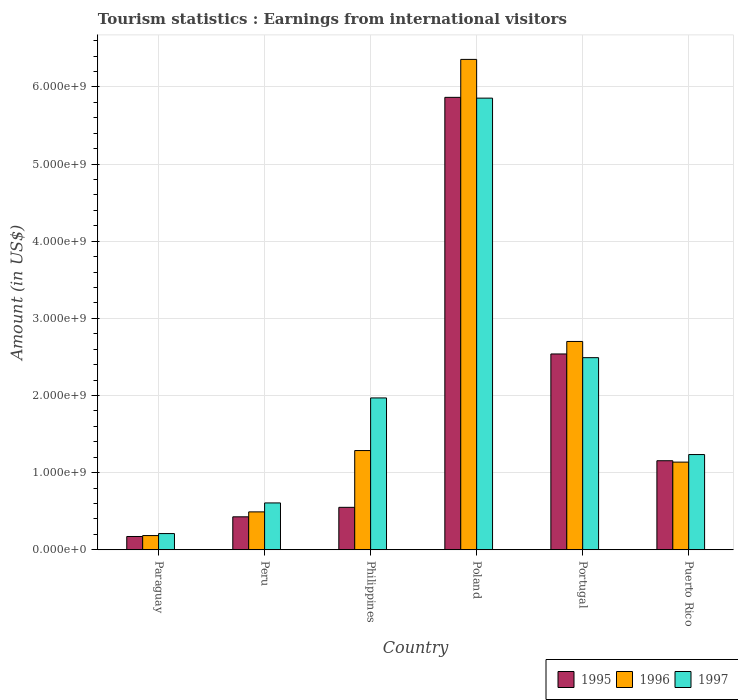How many groups of bars are there?
Offer a terse response. 6. Are the number of bars per tick equal to the number of legend labels?
Make the answer very short. Yes. Are the number of bars on each tick of the X-axis equal?
Offer a very short reply. Yes. How many bars are there on the 6th tick from the right?
Your answer should be very brief. 3. What is the label of the 3rd group of bars from the left?
Provide a succinct answer. Philippines. In how many cases, is the number of bars for a given country not equal to the number of legend labels?
Make the answer very short. 0. What is the earnings from international visitors in 1997 in Puerto Rico?
Offer a terse response. 1.24e+09. Across all countries, what is the maximum earnings from international visitors in 1995?
Your answer should be compact. 5.86e+09. Across all countries, what is the minimum earnings from international visitors in 1996?
Give a very brief answer. 1.85e+08. In which country was the earnings from international visitors in 1996 maximum?
Provide a succinct answer. Poland. In which country was the earnings from international visitors in 1996 minimum?
Your answer should be compact. Paraguay. What is the total earnings from international visitors in 1996 in the graph?
Keep it short and to the point. 1.22e+1. What is the difference between the earnings from international visitors in 1995 in Peru and that in Philippines?
Give a very brief answer. -1.23e+08. What is the difference between the earnings from international visitors in 1997 in Portugal and the earnings from international visitors in 1996 in Philippines?
Your answer should be very brief. 1.20e+09. What is the average earnings from international visitors in 1997 per country?
Provide a short and direct response. 2.06e+09. What is the difference between the earnings from international visitors of/in 1995 and earnings from international visitors of/in 1997 in Puerto Rico?
Your response must be concise. -8.00e+07. What is the ratio of the earnings from international visitors in 1995 in Portugal to that in Puerto Rico?
Your answer should be very brief. 2.2. Is the earnings from international visitors in 1997 in Peru less than that in Portugal?
Keep it short and to the point. Yes. Is the difference between the earnings from international visitors in 1995 in Paraguay and Puerto Rico greater than the difference between the earnings from international visitors in 1997 in Paraguay and Puerto Rico?
Provide a succinct answer. Yes. What is the difference between the highest and the second highest earnings from international visitors in 1996?
Your answer should be very brief. 3.66e+09. What is the difference between the highest and the lowest earnings from international visitors in 1997?
Provide a succinct answer. 5.64e+09. In how many countries, is the earnings from international visitors in 1996 greater than the average earnings from international visitors in 1996 taken over all countries?
Give a very brief answer. 2. Is the sum of the earnings from international visitors in 1995 in Paraguay and Poland greater than the maximum earnings from international visitors in 1996 across all countries?
Provide a succinct answer. No. What does the 2nd bar from the left in Puerto Rico represents?
Offer a terse response. 1996. Is it the case that in every country, the sum of the earnings from international visitors in 1995 and earnings from international visitors in 1996 is greater than the earnings from international visitors in 1997?
Your answer should be very brief. No. Are all the bars in the graph horizontal?
Make the answer very short. No. Are the values on the major ticks of Y-axis written in scientific E-notation?
Ensure brevity in your answer.  Yes. Where does the legend appear in the graph?
Make the answer very short. Bottom right. How are the legend labels stacked?
Give a very brief answer. Horizontal. What is the title of the graph?
Make the answer very short. Tourism statistics : Earnings from international visitors. Does "1961" appear as one of the legend labels in the graph?
Give a very brief answer. No. What is the label or title of the X-axis?
Make the answer very short. Country. What is the Amount (in US$) of 1995 in Paraguay?
Offer a very short reply. 1.73e+08. What is the Amount (in US$) of 1996 in Paraguay?
Keep it short and to the point. 1.85e+08. What is the Amount (in US$) of 1997 in Paraguay?
Make the answer very short. 2.11e+08. What is the Amount (in US$) of 1995 in Peru?
Keep it short and to the point. 4.28e+08. What is the Amount (in US$) of 1996 in Peru?
Offer a very short reply. 4.92e+08. What is the Amount (in US$) of 1997 in Peru?
Your response must be concise. 6.08e+08. What is the Amount (in US$) of 1995 in Philippines?
Your answer should be compact. 5.51e+08. What is the Amount (in US$) in 1996 in Philippines?
Provide a short and direct response. 1.29e+09. What is the Amount (in US$) of 1997 in Philippines?
Provide a short and direct response. 1.97e+09. What is the Amount (in US$) of 1995 in Poland?
Offer a very short reply. 5.86e+09. What is the Amount (in US$) in 1996 in Poland?
Make the answer very short. 6.36e+09. What is the Amount (in US$) of 1997 in Poland?
Your response must be concise. 5.86e+09. What is the Amount (in US$) of 1995 in Portugal?
Give a very brief answer. 2.54e+09. What is the Amount (in US$) of 1996 in Portugal?
Your answer should be very brief. 2.70e+09. What is the Amount (in US$) in 1997 in Portugal?
Make the answer very short. 2.49e+09. What is the Amount (in US$) of 1995 in Puerto Rico?
Provide a short and direct response. 1.16e+09. What is the Amount (in US$) in 1996 in Puerto Rico?
Your response must be concise. 1.14e+09. What is the Amount (in US$) of 1997 in Puerto Rico?
Keep it short and to the point. 1.24e+09. Across all countries, what is the maximum Amount (in US$) of 1995?
Ensure brevity in your answer.  5.86e+09. Across all countries, what is the maximum Amount (in US$) in 1996?
Your answer should be very brief. 6.36e+09. Across all countries, what is the maximum Amount (in US$) of 1997?
Make the answer very short. 5.86e+09. Across all countries, what is the minimum Amount (in US$) in 1995?
Make the answer very short. 1.73e+08. Across all countries, what is the minimum Amount (in US$) in 1996?
Provide a short and direct response. 1.85e+08. Across all countries, what is the minimum Amount (in US$) of 1997?
Offer a very short reply. 2.11e+08. What is the total Amount (in US$) of 1995 in the graph?
Ensure brevity in your answer.  1.07e+1. What is the total Amount (in US$) in 1996 in the graph?
Give a very brief answer. 1.22e+1. What is the total Amount (in US$) of 1997 in the graph?
Your response must be concise. 1.24e+1. What is the difference between the Amount (in US$) of 1995 in Paraguay and that in Peru?
Your answer should be very brief. -2.55e+08. What is the difference between the Amount (in US$) in 1996 in Paraguay and that in Peru?
Make the answer very short. -3.07e+08. What is the difference between the Amount (in US$) in 1997 in Paraguay and that in Peru?
Keep it short and to the point. -3.97e+08. What is the difference between the Amount (in US$) in 1995 in Paraguay and that in Philippines?
Ensure brevity in your answer.  -3.78e+08. What is the difference between the Amount (in US$) in 1996 in Paraguay and that in Philippines?
Provide a succinct answer. -1.10e+09. What is the difference between the Amount (in US$) in 1997 in Paraguay and that in Philippines?
Provide a succinct answer. -1.76e+09. What is the difference between the Amount (in US$) in 1995 in Paraguay and that in Poland?
Your answer should be very brief. -5.69e+09. What is the difference between the Amount (in US$) in 1996 in Paraguay and that in Poland?
Ensure brevity in your answer.  -6.17e+09. What is the difference between the Amount (in US$) in 1997 in Paraguay and that in Poland?
Ensure brevity in your answer.  -5.64e+09. What is the difference between the Amount (in US$) of 1995 in Paraguay and that in Portugal?
Give a very brief answer. -2.37e+09. What is the difference between the Amount (in US$) of 1996 in Paraguay and that in Portugal?
Make the answer very short. -2.52e+09. What is the difference between the Amount (in US$) in 1997 in Paraguay and that in Portugal?
Ensure brevity in your answer.  -2.28e+09. What is the difference between the Amount (in US$) of 1995 in Paraguay and that in Puerto Rico?
Offer a very short reply. -9.82e+08. What is the difference between the Amount (in US$) in 1996 in Paraguay and that in Puerto Rico?
Offer a very short reply. -9.52e+08. What is the difference between the Amount (in US$) in 1997 in Paraguay and that in Puerto Rico?
Offer a very short reply. -1.02e+09. What is the difference between the Amount (in US$) of 1995 in Peru and that in Philippines?
Provide a succinct answer. -1.23e+08. What is the difference between the Amount (in US$) of 1996 in Peru and that in Philippines?
Your answer should be very brief. -7.95e+08. What is the difference between the Amount (in US$) in 1997 in Peru and that in Philippines?
Keep it short and to the point. -1.36e+09. What is the difference between the Amount (in US$) of 1995 in Peru and that in Poland?
Offer a very short reply. -5.44e+09. What is the difference between the Amount (in US$) of 1996 in Peru and that in Poland?
Your answer should be very brief. -5.86e+09. What is the difference between the Amount (in US$) of 1997 in Peru and that in Poland?
Your answer should be compact. -5.25e+09. What is the difference between the Amount (in US$) of 1995 in Peru and that in Portugal?
Keep it short and to the point. -2.11e+09. What is the difference between the Amount (in US$) in 1996 in Peru and that in Portugal?
Ensure brevity in your answer.  -2.21e+09. What is the difference between the Amount (in US$) of 1997 in Peru and that in Portugal?
Your answer should be compact. -1.88e+09. What is the difference between the Amount (in US$) of 1995 in Peru and that in Puerto Rico?
Provide a succinct answer. -7.27e+08. What is the difference between the Amount (in US$) in 1996 in Peru and that in Puerto Rico?
Offer a terse response. -6.45e+08. What is the difference between the Amount (in US$) in 1997 in Peru and that in Puerto Rico?
Your response must be concise. -6.27e+08. What is the difference between the Amount (in US$) in 1995 in Philippines and that in Poland?
Provide a short and direct response. -5.31e+09. What is the difference between the Amount (in US$) in 1996 in Philippines and that in Poland?
Give a very brief answer. -5.07e+09. What is the difference between the Amount (in US$) in 1997 in Philippines and that in Poland?
Keep it short and to the point. -3.89e+09. What is the difference between the Amount (in US$) of 1995 in Philippines and that in Portugal?
Provide a short and direct response. -1.99e+09. What is the difference between the Amount (in US$) in 1996 in Philippines and that in Portugal?
Your answer should be compact. -1.41e+09. What is the difference between the Amount (in US$) in 1997 in Philippines and that in Portugal?
Provide a succinct answer. -5.22e+08. What is the difference between the Amount (in US$) of 1995 in Philippines and that in Puerto Rico?
Your answer should be very brief. -6.04e+08. What is the difference between the Amount (in US$) of 1996 in Philippines and that in Puerto Rico?
Give a very brief answer. 1.50e+08. What is the difference between the Amount (in US$) of 1997 in Philippines and that in Puerto Rico?
Your answer should be compact. 7.34e+08. What is the difference between the Amount (in US$) of 1995 in Poland and that in Portugal?
Offer a very short reply. 3.33e+09. What is the difference between the Amount (in US$) in 1996 in Poland and that in Portugal?
Your answer should be compact. 3.66e+09. What is the difference between the Amount (in US$) in 1997 in Poland and that in Portugal?
Offer a terse response. 3.36e+09. What is the difference between the Amount (in US$) of 1995 in Poland and that in Puerto Rico?
Your answer should be very brief. 4.71e+09. What is the difference between the Amount (in US$) of 1996 in Poland and that in Puerto Rico?
Make the answer very short. 5.22e+09. What is the difference between the Amount (in US$) of 1997 in Poland and that in Puerto Rico?
Provide a short and direct response. 4.62e+09. What is the difference between the Amount (in US$) of 1995 in Portugal and that in Puerto Rico?
Offer a terse response. 1.38e+09. What is the difference between the Amount (in US$) in 1996 in Portugal and that in Puerto Rico?
Your answer should be very brief. 1.56e+09. What is the difference between the Amount (in US$) of 1997 in Portugal and that in Puerto Rico?
Offer a terse response. 1.26e+09. What is the difference between the Amount (in US$) of 1995 in Paraguay and the Amount (in US$) of 1996 in Peru?
Your response must be concise. -3.19e+08. What is the difference between the Amount (in US$) of 1995 in Paraguay and the Amount (in US$) of 1997 in Peru?
Your answer should be compact. -4.35e+08. What is the difference between the Amount (in US$) of 1996 in Paraguay and the Amount (in US$) of 1997 in Peru?
Your answer should be compact. -4.23e+08. What is the difference between the Amount (in US$) of 1995 in Paraguay and the Amount (in US$) of 1996 in Philippines?
Give a very brief answer. -1.11e+09. What is the difference between the Amount (in US$) in 1995 in Paraguay and the Amount (in US$) in 1997 in Philippines?
Your answer should be compact. -1.80e+09. What is the difference between the Amount (in US$) in 1996 in Paraguay and the Amount (in US$) in 1997 in Philippines?
Your answer should be very brief. -1.78e+09. What is the difference between the Amount (in US$) of 1995 in Paraguay and the Amount (in US$) of 1996 in Poland?
Give a very brief answer. -6.18e+09. What is the difference between the Amount (in US$) of 1995 in Paraguay and the Amount (in US$) of 1997 in Poland?
Offer a terse response. -5.68e+09. What is the difference between the Amount (in US$) in 1996 in Paraguay and the Amount (in US$) in 1997 in Poland?
Ensure brevity in your answer.  -5.67e+09. What is the difference between the Amount (in US$) in 1995 in Paraguay and the Amount (in US$) in 1996 in Portugal?
Your answer should be very brief. -2.53e+09. What is the difference between the Amount (in US$) of 1995 in Paraguay and the Amount (in US$) of 1997 in Portugal?
Your response must be concise. -2.32e+09. What is the difference between the Amount (in US$) of 1996 in Paraguay and the Amount (in US$) of 1997 in Portugal?
Provide a short and direct response. -2.31e+09. What is the difference between the Amount (in US$) in 1995 in Paraguay and the Amount (in US$) in 1996 in Puerto Rico?
Offer a very short reply. -9.64e+08. What is the difference between the Amount (in US$) of 1995 in Paraguay and the Amount (in US$) of 1997 in Puerto Rico?
Keep it short and to the point. -1.06e+09. What is the difference between the Amount (in US$) in 1996 in Paraguay and the Amount (in US$) in 1997 in Puerto Rico?
Offer a terse response. -1.05e+09. What is the difference between the Amount (in US$) in 1995 in Peru and the Amount (in US$) in 1996 in Philippines?
Offer a very short reply. -8.59e+08. What is the difference between the Amount (in US$) of 1995 in Peru and the Amount (in US$) of 1997 in Philippines?
Keep it short and to the point. -1.54e+09. What is the difference between the Amount (in US$) of 1996 in Peru and the Amount (in US$) of 1997 in Philippines?
Provide a succinct answer. -1.48e+09. What is the difference between the Amount (in US$) of 1995 in Peru and the Amount (in US$) of 1996 in Poland?
Ensure brevity in your answer.  -5.93e+09. What is the difference between the Amount (in US$) of 1995 in Peru and the Amount (in US$) of 1997 in Poland?
Ensure brevity in your answer.  -5.43e+09. What is the difference between the Amount (in US$) of 1996 in Peru and the Amount (in US$) of 1997 in Poland?
Your answer should be very brief. -5.36e+09. What is the difference between the Amount (in US$) of 1995 in Peru and the Amount (in US$) of 1996 in Portugal?
Provide a succinct answer. -2.27e+09. What is the difference between the Amount (in US$) in 1995 in Peru and the Amount (in US$) in 1997 in Portugal?
Your answer should be very brief. -2.06e+09. What is the difference between the Amount (in US$) in 1996 in Peru and the Amount (in US$) in 1997 in Portugal?
Your answer should be very brief. -2.00e+09. What is the difference between the Amount (in US$) of 1995 in Peru and the Amount (in US$) of 1996 in Puerto Rico?
Give a very brief answer. -7.09e+08. What is the difference between the Amount (in US$) in 1995 in Peru and the Amount (in US$) in 1997 in Puerto Rico?
Give a very brief answer. -8.07e+08. What is the difference between the Amount (in US$) in 1996 in Peru and the Amount (in US$) in 1997 in Puerto Rico?
Offer a very short reply. -7.43e+08. What is the difference between the Amount (in US$) in 1995 in Philippines and the Amount (in US$) in 1996 in Poland?
Make the answer very short. -5.81e+09. What is the difference between the Amount (in US$) of 1995 in Philippines and the Amount (in US$) of 1997 in Poland?
Provide a succinct answer. -5.30e+09. What is the difference between the Amount (in US$) in 1996 in Philippines and the Amount (in US$) in 1997 in Poland?
Provide a short and direct response. -4.57e+09. What is the difference between the Amount (in US$) of 1995 in Philippines and the Amount (in US$) of 1996 in Portugal?
Provide a succinct answer. -2.15e+09. What is the difference between the Amount (in US$) in 1995 in Philippines and the Amount (in US$) in 1997 in Portugal?
Your answer should be very brief. -1.94e+09. What is the difference between the Amount (in US$) in 1996 in Philippines and the Amount (in US$) in 1997 in Portugal?
Your answer should be compact. -1.20e+09. What is the difference between the Amount (in US$) of 1995 in Philippines and the Amount (in US$) of 1996 in Puerto Rico?
Provide a short and direct response. -5.86e+08. What is the difference between the Amount (in US$) in 1995 in Philippines and the Amount (in US$) in 1997 in Puerto Rico?
Your response must be concise. -6.84e+08. What is the difference between the Amount (in US$) of 1996 in Philippines and the Amount (in US$) of 1997 in Puerto Rico?
Your answer should be very brief. 5.20e+07. What is the difference between the Amount (in US$) in 1995 in Poland and the Amount (in US$) in 1996 in Portugal?
Provide a succinct answer. 3.16e+09. What is the difference between the Amount (in US$) of 1995 in Poland and the Amount (in US$) of 1997 in Portugal?
Offer a very short reply. 3.37e+09. What is the difference between the Amount (in US$) of 1996 in Poland and the Amount (in US$) of 1997 in Portugal?
Ensure brevity in your answer.  3.87e+09. What is the difference between the Amount (in US$) of 1995 in Poland and the Amount (in US$) of 1996 in Puerto Rico?
Give a very brief answer. 4.73e+09. What is the difference between the Amount (in US$) of 1995 in Poland and the Amount (in US$) of 1997 in Puerto Rico?
Give a very brief answer. 4.63e+09. What is the difference between the Amount (in US$) in 1996 in Poland and the Amount (in US$) in 1997 in Puerto Rico?
Ensure brevity in your answer.  5.12e+09. What is the difference between the Amount (in US$) of 1995 in Portugal and the Amount (in US$) of 1996 in Puerto Rico?
Keep it short and to the point. 1.40e+09. What is the difference between the Amount (in US$) in 1995 in Portugal and the Amount (in US$) in 1997 in Puerto Rico?
Keep it short and to the point. 1.30e+09. What is the difference between the Amount (in US$) in 1996 in Portugal and the Amount (in US$) in 1997 in Puerto Rico?
Provide a short and direct response. 1.47e+09. What is the average Amount (in US$) in 1995 per country?
Keep it short and to the point. 1.79e+09. What is the average Amount (in US$) of 1996 per country?
Your answer should be compact. 2.03e+09. What is the average Amount (in US$) in 1997 per country?
Your response must be concise. 2.06e+09. What is the difference between the Amount (in US$) in 1995 and Amount (in US$) in 1996 in Paraguay?
Give a very brief answer. -1.20e+07. What is the difference between the Amount (in US$) in 1995 and Amount (in US$) in 1997 in Paraguay?
Keep it short and to the point. -3.80e+07. What is the difference between the Amount (in US$) in 1996 and Amount (in US$) in 1997 in Paraguay?
Offer a very short reply. -2.60e+07. What is the difference between the Amount (in US$) of 1995 and Amount (in US$) of 1996 in Peru?
Offer a terse response. -6.40e+07. What is the difference between the Amount (in US$) in 1995 and Amount (in US$) in 1997 in Peru?
Your answer should be compact. -1.80e+08. What is the difference between the Amount (in US$) in 1996 and Amount (in US$) in 1997 in Peru?
Make the answer very short. -1.16e+08. What is the difference between the Amount (in US$) in 1995 and Amount (in US$) in 1996 in Philippines?
Your answer should be very brief. -7.36e+08. What is the difference between the Amount (in US$) in 1995 and Amount (in US$) in 1997 in Philippines?
Keep it short and to the point. -1.42e+09. What is the difference between the Amount (in US$) of 1996 and Amount (in US$) of 1997 in Philippines?
Your answer should be very brief. -6.82e+08. What is the difference between the Amount (in US$) in 1995 and Amount (in US$) in 1996 in Poland?
Offer a terse response. -4.92e+08. What is the difference between the Amount (in US$) in 1995 and Amount (in US$) in 1997 in Poland?
Give a very brief answer. 1.00e+07. What is the difference between the Amount (in US$) of 1996 and Amount (in US$) of 1997 in Poland?
Your response must be concise. 5.02e+08. What is the difference between the Amount (in US$) of 1995 and Amount (in US$) of 1996 in Portugal?
Your response must be concise. -1.62e+08. What is the difference between the Amount (in US$) of 1995 and Amount (in US$) of 1997 in Portugal?
Your response must be concise. 4.80e+07. What is the difference between the Amount (in US$) in 1996 and Amount (in US$) in 1997 in Portugal?
Your response must be concise. 2.10e+08. What is the difference between the Amount (in US$) in 1995 and Amount (in US$) in 1996 in Puerto Rico?
Offer a very short reply. 1.80e+07. What is the difference between the Amount (in US$) of 1995 and Amount (in US$) of 1997 in Puerto Rico?
Your answer should be very brief. -8.00e+07. What is the difference between the Amount (in US$) in 1996 and Amount (in US$) in 1997 in Puerto Rico?
Make the answer very short. -9.80e+07. What is the ratio of the Amount (in US$) in 1995 in Paraguay to that in Peru?
Your answer should be compact. 0.4. What is the ratio of the Amount (in US$) in 1996 in Paraguay to that in Peru?
Keep it short and to the point. 0.38. What is the ratio of the Amount (in US$) of 1997 in Paraguay to that in Peru?
Make the answer very short. 0.35. What is the ratio of the Amount (in US$) of 1995 in Paraguay to that in Philippines?
Make the answer very short. 0.31. What is the ratio of the Amount (in US$) in 1996 in Paraguay to that in Philippines?
Your answer should be very brief. 0.14. What is the ratio of the Amount (in US$) in 1997 in Paraguay to that in Philippines?
Your answer should be compact. 0.11. What is the ratio of the Amount (in US$) of 1995 in Paraguay to that in Poland?
Give a very brief answer. 0.03. What is the ratio of the Amount (in US$) of 1996 in Paraguay to that in Poland?
Offer a very short reply. 0.03. What is the ratio of the Amount (in US$) of 1997 in Paraguay to that in Poland?
Provide a succinct answer. 0.04. What is the ratio of the Amount (in US$) of 1995 in Paraguay to that in Portugal?
Your answer should be very brief. 0.07. What is the ratio of the Amount (in US$) of 1996 in Paraguay to that in Portugal?
Ensure brevity in your answer.  0.07. What is the ratio of the Amount (in US$) in 1997 in Paraguay to that in Portugal?
Give a very brief answer. 0.08. What is the ratio of the Amount (in US$) of 1995 in Paraguay to that in Puerto Rico?
Offer a very short reply. 0.15. What is the ratio of the Amount (in US$) in 1996 in Paraguay to that in Puerto Rico?
Ensure brevity in your answer.  0.16. What is the ratio of the Amount (in US$) of 1997 in Paraguay to that in Puerto Rico?
Your answer should be very brief. 0.17. What is the ratio of the Amount (in US$) of 1995 in Peru to that in Philippines?
Provide a short and direct response. 0.78. What is the ratio of the Amount (in US$) of 1996 in Peru to that in Philippines?
Your answer should be compact. 0.38. What is the ratio of the Amount (in US$) in 1997 in Peru to that in Philippines?
Your response must be concise. 0.31. What is the ratio of the Amount (in US$) in 1995 in Peru to that in Poland?
Offer a terse response. 0.07. What is the ratio of the Amount (in US$) in 1996 in Peru to that in Poland?
Keep it short and to the point. 0.08. What is the ratio of the Amount (in US$) of 1997 in Peru to that in Poland?
Provide a succinct answer. 0.1. What is the ratio of the Amount (in US$) of 1995 in Peru to that in Portugal?
Provide a short and direct response. 0.17. What is the ratio of the Amount (in US$) in 1996 in Peru to that in Portugal?
Give a very brief answer. 0.18. What is the ratio of the Amount (in US$) in 1997 in Peru to that in Portugal?
Offer a terse response. 0.24. What is the ratio of the Amount (in US$) of 1995 in Peru to that in Puerto Rico?
Give a very brief answer. 0.37. What is the ratio of the Amount (in US$) in 1996 in Peru to that in Puerto Rico?
Give a very brief answer. 0.43. What is the ratio of the Amount (in US$) in 1997 in Peru to that in Puerto Rico?
Your answer should be very brief. 0.49. What is the ratio of the Amount (in US$) in 1995 in Philippines to that in Poland?
Provide a succinct answer. 0.09. What is the ratio of the Amount (in US$) of 1996 in Philippines to that in Poland?
Ensure brevity in your answer.  0.2. What is the ratio of the Amount (in US$) of 1997 in Philippines to that in Poland?
Offer a terse response. 0.34. What is the ratio of the Amount (in US$) of 1995 in Philippines to that in Portugal?
Keep it short and to the point. 0.22. What is the ratio of the Amount (in US$) in 1996 in Philippines to that in Portugal?
Keep it short and to the point. 0.48. What is the ratio of the Amount (in US$) in 1997 in Philippines to that in Portugal?
Make the answer very short. 0.79. What is the ratio of the Amount (in US$) of 1995 in Philippines to that in Puerto Rico?
Provide a succinct answer. 0.48. What is the ratio of the Amount (in US$) of 1996 in Philippines to that in Puerto Rico?
Provide a short and direct response. 1.13. What is the ratio of the Amount (in US$) of 1997 in Philippines to that in Puerto Rico?
Offer a terse response. 1.59. What is the ratio of the Amount (in US$) of 1995 in Poland to that in Portugal?
Provide a short and direct response. 2.31. What is the ratio of the Amount (in US$) in 1996 in Poland to that in Portugal?
Your answer should be compact. 2.35. What is the ratio of the Amount (in US$) of 1997 in Poland to that in Portugal?
Keep it short and to the point. 2.35. What is the ratio of the Amount (in US$) of 1995 in Poland to that in Puerto Rico?
Provide a succinct answer. 5.08. What is the ratio of the Amount (in US$) in 1996 in Poland to that in Puerto Rico?
Your answer should be very brief. 5.59. What is the ratio of the Amount (in US$) of 1997 in Poland to that in Puerto Rico?
Provide a short and direct response. 4.74. What is the ratio of the Amount (in US$) in 1995 in Portugal to that in Puerto Rico?
Ensure brevity in your answer.  2.2. What is the ratio of the Amount (in US$) of 1996 in Portugal to that in Puerto Rico?
Your response must be concise. 2.38. What is the ratio of the Amount (in US$) in 1997 in Portugal to that in Puerto Rico?
Your answer should be very brief. 2.02. What is the difference between the highest and the second highest Amount (in US$) of 1995?
Your answer should be compact. 3.33e+09. What is the difference between the highest and the second highest Amount (in US$) in 1996?
Ensure brevity in your answer.  3.66e+09. What is the difference between the highest and the second highest Amount (in US$) of 1997?
Provide a succinct answer. 3.36e+09. What is the difference between the highest and the lowest Amount (in US$) of 1995?
Keep it short and to the point. 5.69e+09. What is the difference between the highest and the lowest Amount (in US$) in 1996?
Keep it short and to the point. 6.17e+09. What is the difference between the highest and the lowest Amount (in US$) of 1997?
Ensure brevity in your answer.  5.64e+09. 